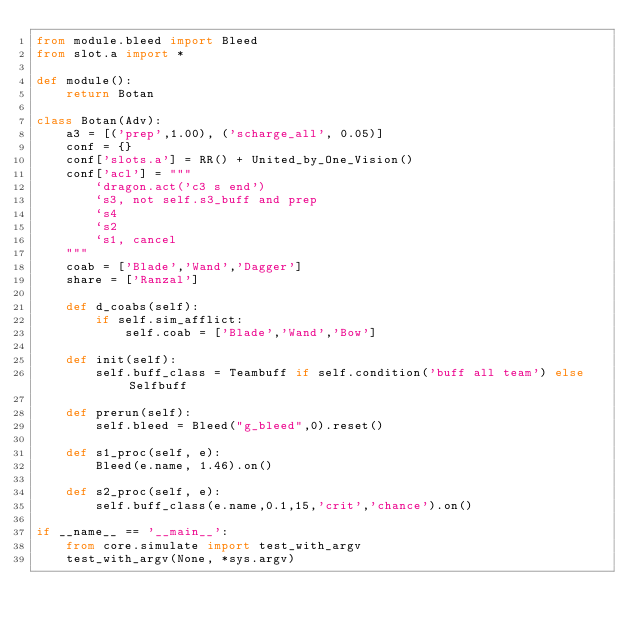Convert code to text. <code><loc_0><loc_0><loc_500><loc_500><_Python_>from module.bleed import Bleed
from slot.a import *

def module():
    return Botan

class Botan(Adv):
    a3 = [('prep',1.00), ('scharge_all', 0.05)]
    conf = {}
    conf['slots.a'] = RR() + United_by_One_Vision()
    conf['acl'] = """
        `dragon.act('c3 s end')
        `s3, not self.s3_buff and prep
        `s4
        `s2
        `s1, cancel
    """
    coab = ['Blade','Wand','Dagger']
    share = ['Ranzal']

    def d_coabs(self):
        if self.sim_afflict:
            self.coab = ['Blade','Wand','Bow']

    def init(self):
        self.buff_class = Teambuff if self.condition('buff all team') else Selfbuff
    
    def prerun(self):
        self.bleed = Bleed("g_bleed",0).reset()

    def s1_proc(self, e):
        Bleed(e.name, 1.46).on()

    def s2_proc(self, e):
        self.buff_class(e.name,0.1,15,'crit','chance').on()

if __name__ == '__main__':
    from core.simulate import test_with_argv
    test_with_argv(None, *sys.argv)</code> 